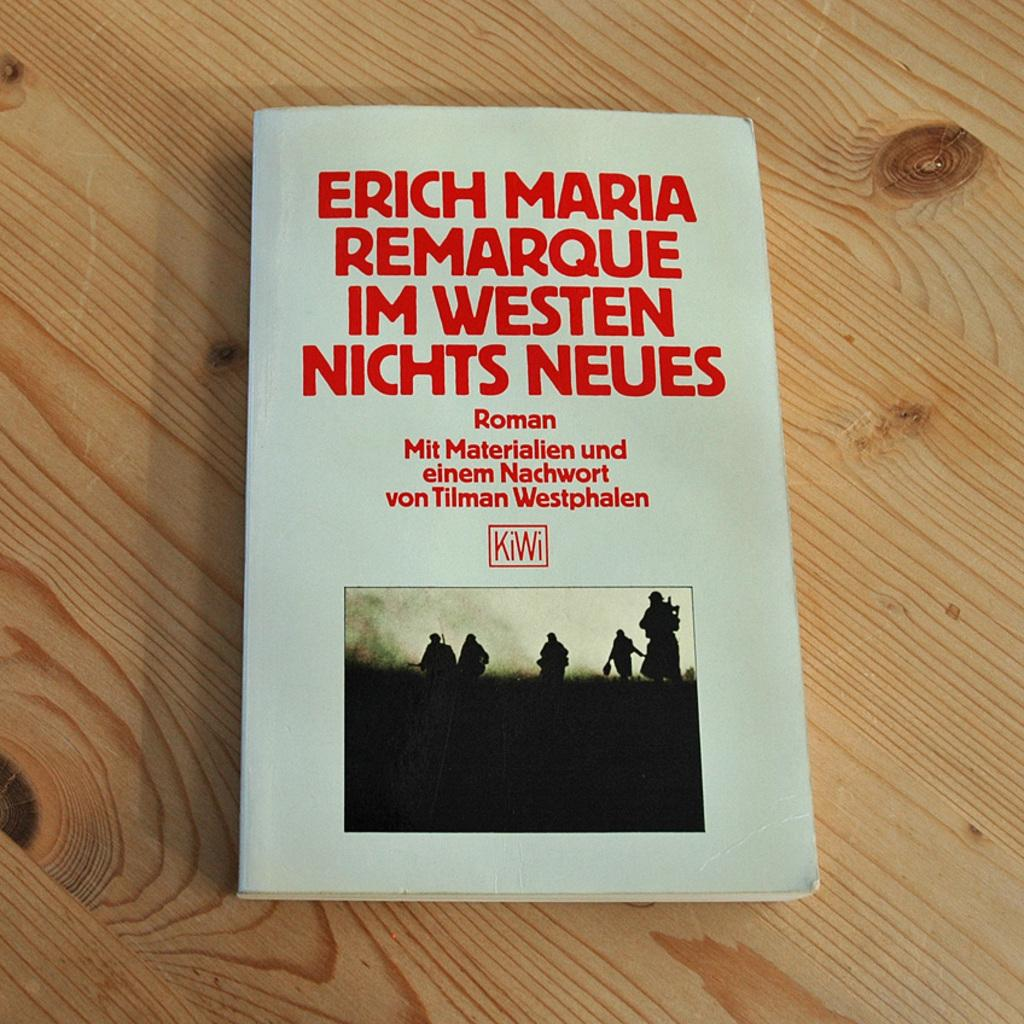Provide a one-sentence caption for the provided image. The novel is titled Remarque Im Westen Nichts Neues. 